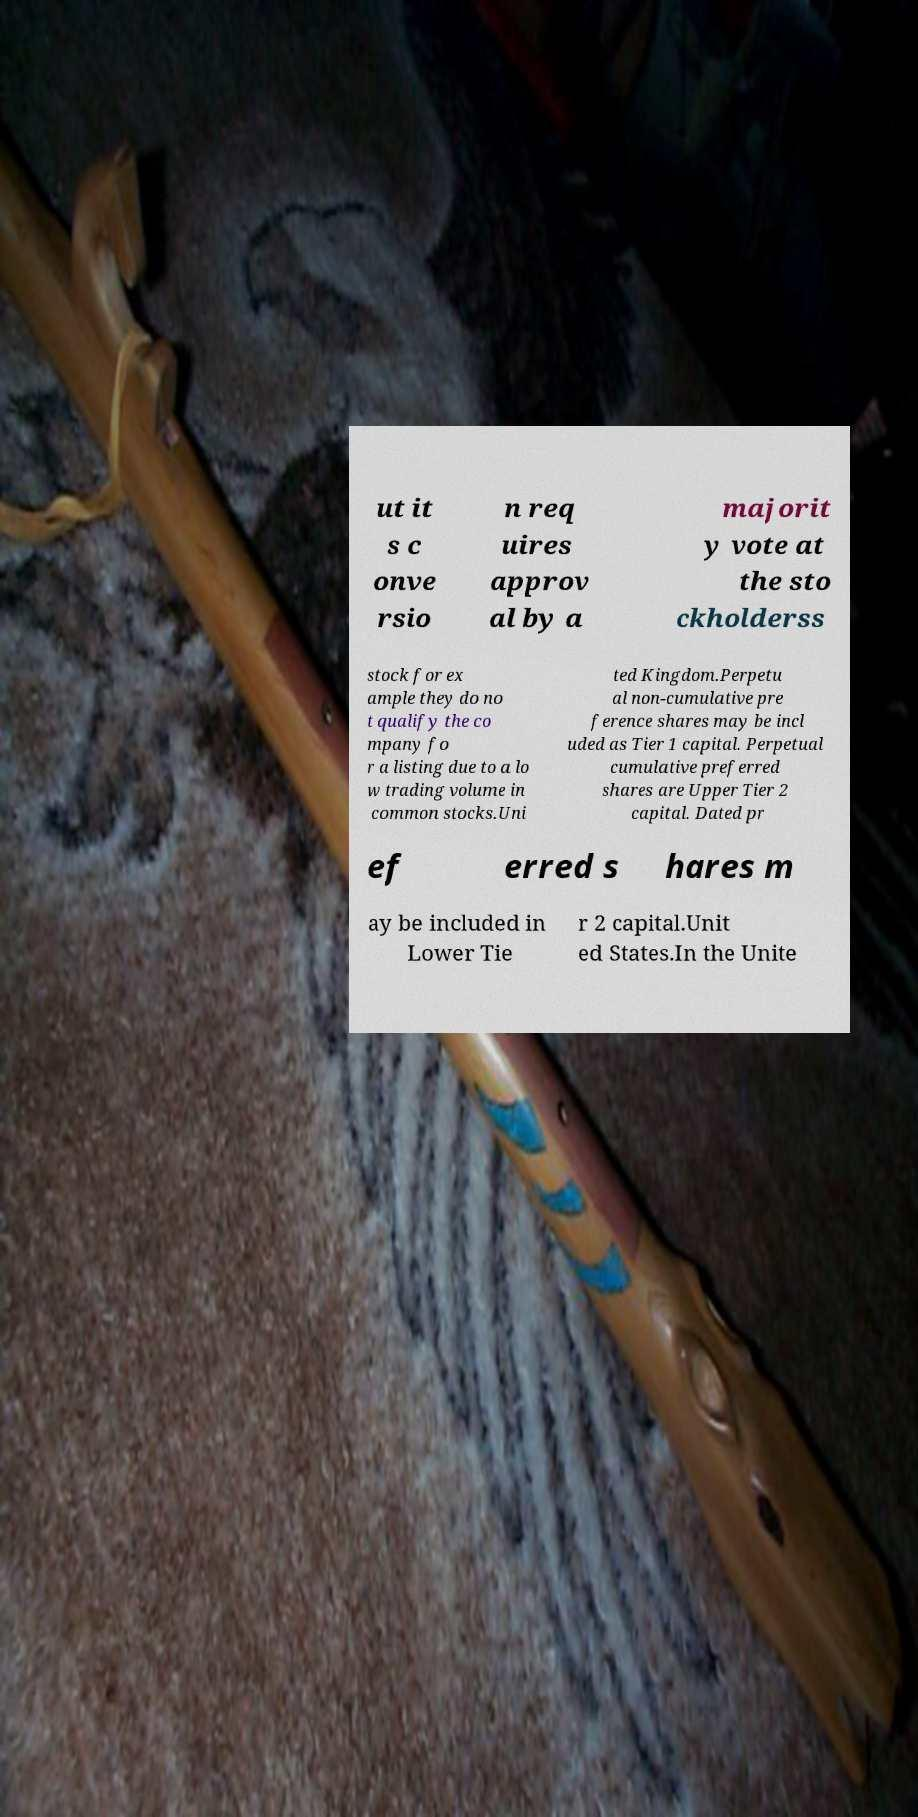There's text embedded in this image that I need extracted. Can you transcribe it verbatim? ut it s c onve rsio n req uires approv al by a majorit y vote at the sto ckholderss stock for ex ample they do no t qualify the co mpany fo r a listing due to a lo w trading volume in common stocks.Uni ted Kingdom.Perpetu al non-cumulative pre ference shares may be incl uded as Tier 1 capital. Perpetual cumulative preferred shares are Upper Tier 2 capital. Dated pr ef erred s hares m ay be included in Lower Tie r 2 capital.Unit ed States.In the Unite 